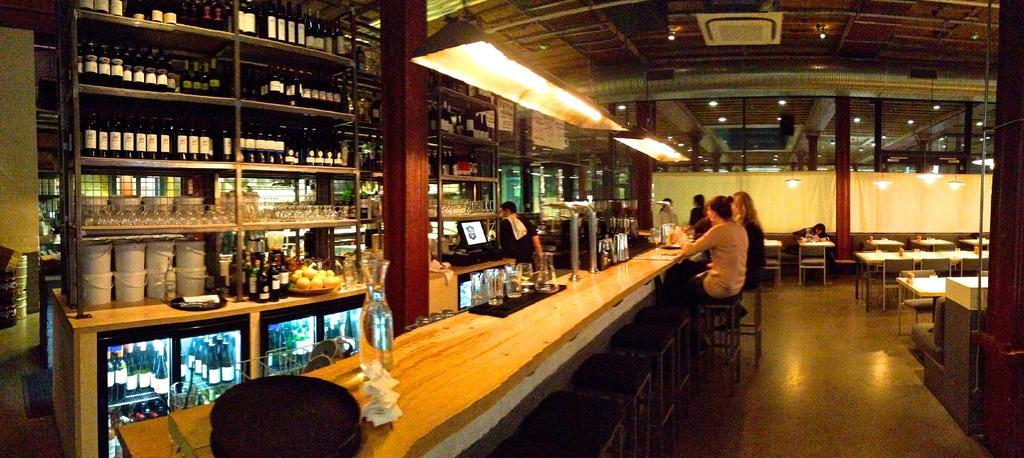Can you describe this image briefly? In this picture there are three persons sitting on a stool and there is a table in front of them which has few objects on it and there are few wine bottles and glasses in front of them and there are few other persons in the background and there are few tables and chairs in the right corner. 